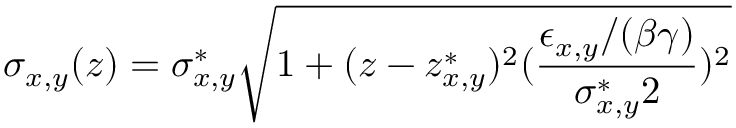Convert formula to latex. <formula><loc_0><loc_0><loc_500><loc_500>\sigma _ { x , y } ( z ) = \sigma _ { x , y } ^ { * } \sqrt { 1 + ( z - z _ { x , y } ^ { * } ) ^ { 2 } ( \frac { \epsilon _ { x , y } / ( \beta \gamma ) } { \sigma _ { x , y } ^ { * } 2 } ) ^ { 2 } }</formula> 